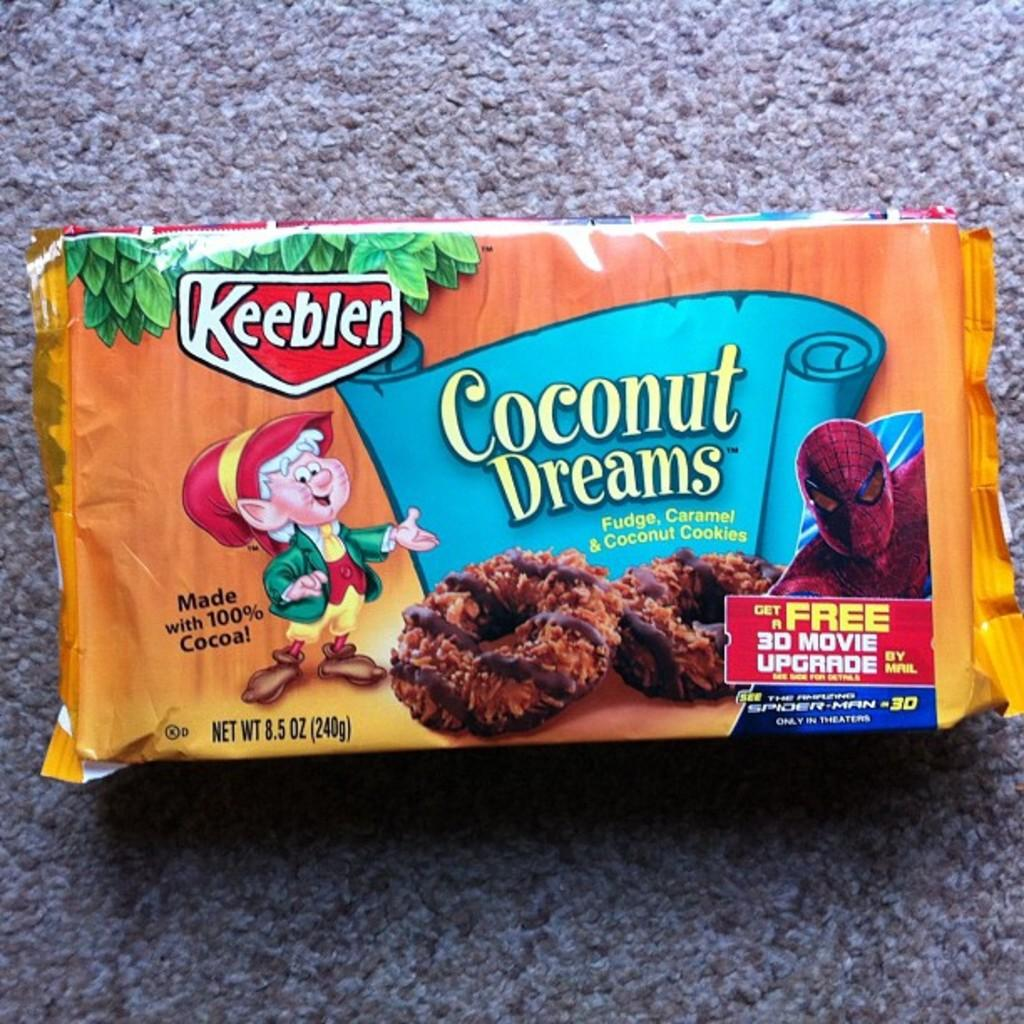What is present on the floor in the image? There is a cookies packet on the floor in the image. What is the color of the cookies packet? The cookies packet is in orange color. What type of crime is being committed in the image? There is no crime or police presence depicted in the image; it simply shows a cookies packet on the floor. 